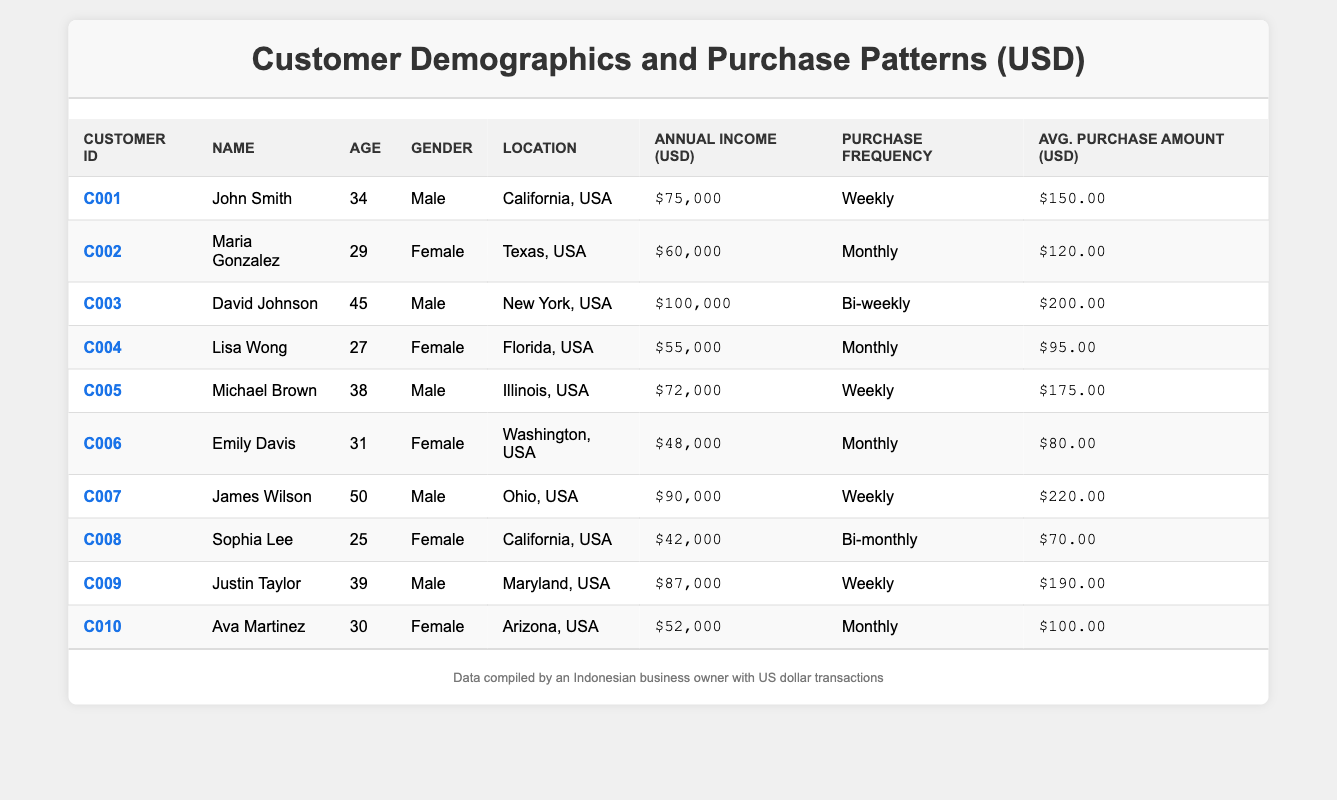What is the annual income of Lisa Wong? Looking at the table, Lisa Wong's annual income is listed under "Annual Income (USD)" as $55,000.
Answer: $55,000 How often does James Wilson make purchases? Referring to the "Purchase Frequency" column, James Wilson is indicated to make purchases "Weekly."
Answer: Weekly Who has the highest average purchase amount? By examining the "Avg. Purchase Amount (USD)" column, James Wilson has the highest amount at $220.00.
Answer: James Wilson What is the average annual income of all the customers? Adding all the annual incomes: 75000 + 60000 + 100000 + 55000 + 72000 + 48000 + 90000 + 42000 + 87000 + 52000 =  535000; there are 10 customers so the average is 535000 / 10 = 53500.
Answer: $53,500 Are there any customers from Florida who purchase weekly? The table shows Lisa Wong is from Florida and has a "Monthly" purchase frequency, while James Wilson and Michael Brown, who are from different states, purchase "Weekly."
Answer: No What percentage of customers have a purchase frequency of "Monthly"? There are 10 customers, 3 of whom have "Monthly" purchases (Maria Gonzalez, Lisa Wong, and Emily Davis). To find the percentage, (3 / 10) * 100 = 30%.
Answer: 30% Which gender has the highest average purchase amount? Calculating separately: Males (John Smith $150 + David Johnson $200 + Michael Brown $175 + James Wilson $220 + Justin Taylor $190 = $935 / 5 = $187) and Females (Maria Gonzalez $120 + Lisa Wong $95 + Emily Davis $80 + Sophia Lee $70 + Ava Martinez $100 = $465 / 5 = $93). Males have a higher average at $187.
Answer: Males What is the total average purchase amount for customers in California? The customers from California are John Smith ($150) and Sophia Lee ($70); adding these gives $150 + $70 = $220.
Answer: $220 Is there a customer with an annual income below $50,000? Emily Davis has an annual income of $48,000, which is below $50,000.
Answer: Yes How many customers are from the state of Texas? There is only one listed customer from Texas: Maria Gonzalez.
Answer: 1 